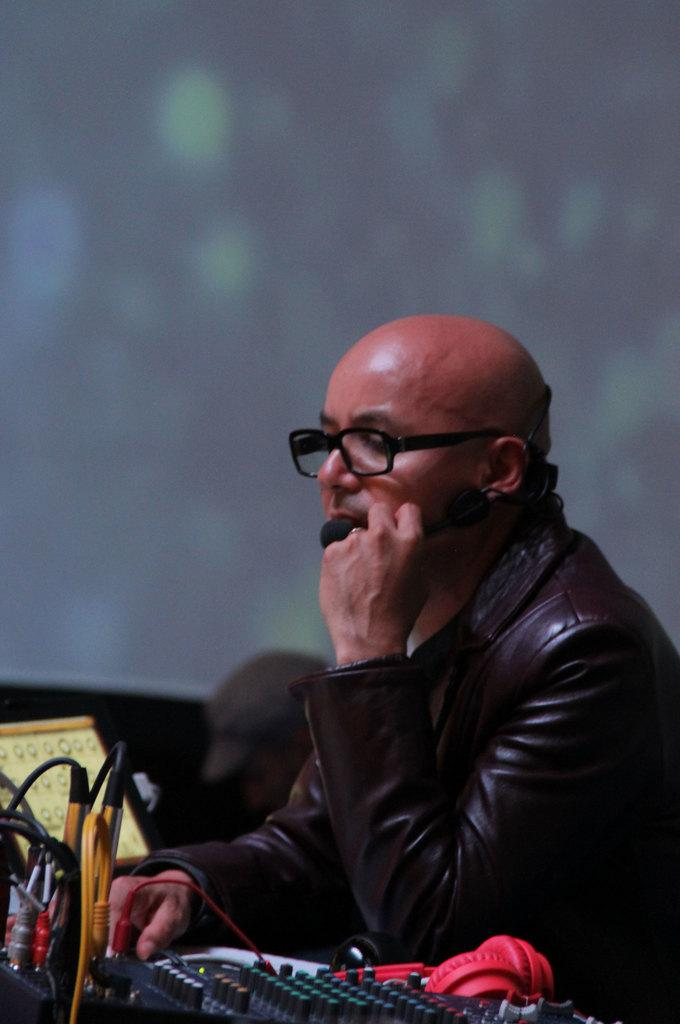Who is present in the image? There is a man in the image. What is the man wearing? The man is wearing a brown jacket. What else can be seen in the image besides the man? There are equipment and wires visible in the image. Can you describe the background of the image? The background of the image is blurred. What type of iron can be seen in the man's hand in the image? There is no iron present in the image; the man is not holding any iron object. 